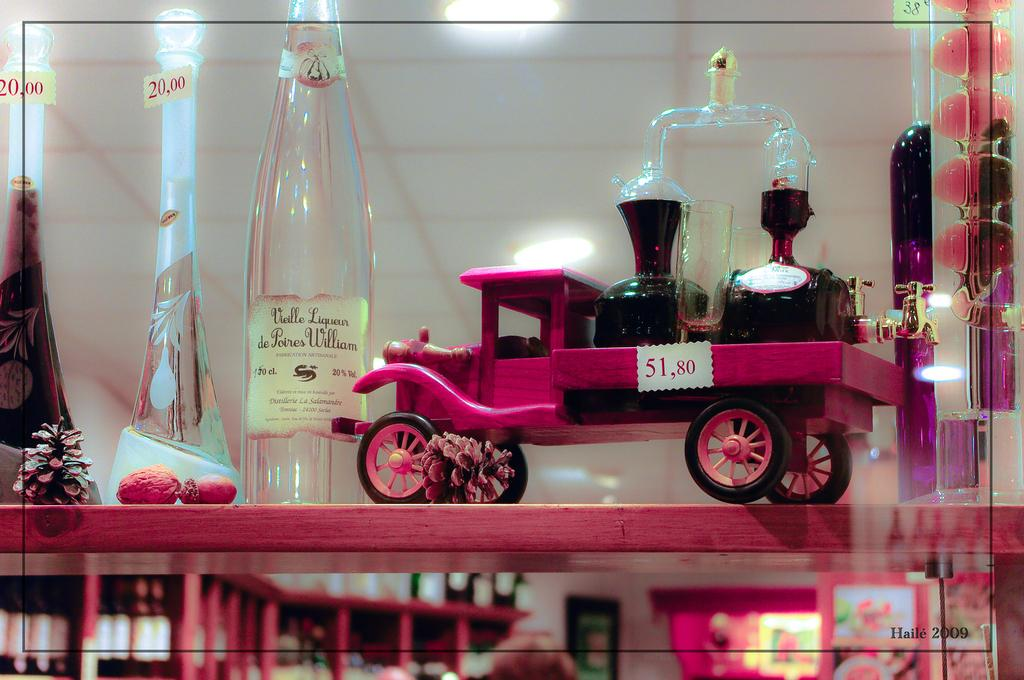What is the main object in the image? There is a table in the image. What is on the table? The table contains bottles and a toy. What can be seen on the ceiling in the image? There are lights on the ceiling. Where are the lights located in the image? The lights are at the top of the image. How would you describe the background of the image? The background of the image is blurred. What type of protest is happening in the image? There is no protest present in the image; it features a table with bottles and a toy, lights on the ceiling, and a blurred background. Can you see someone kicking a ball in the image? There is no ball or person kicking a ball in the image. 